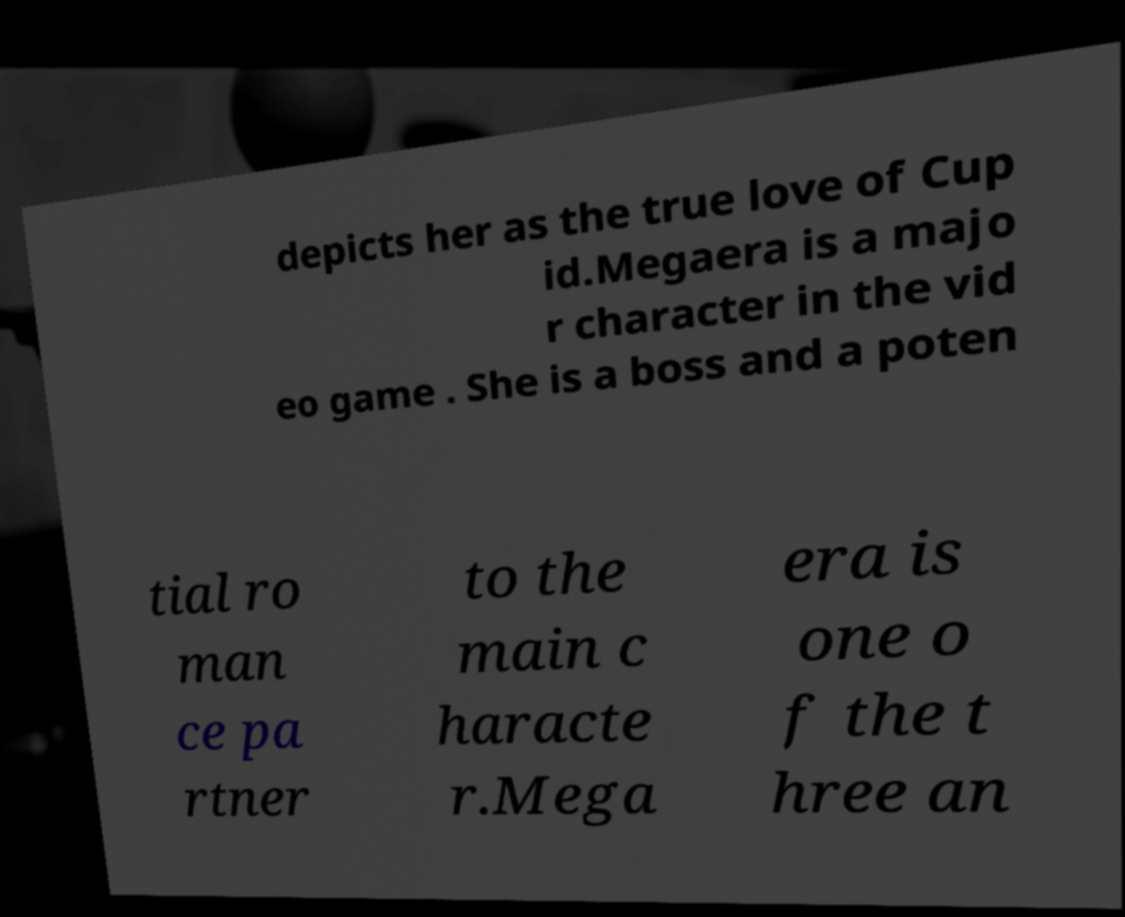I need the written content from this picture converted into text. Can you do that? depicts her as the true love of Cup id.Megaera is a majo r character in the vid eo game . She is a boss and a poten tial ro man ce pa rtner to the main c haracte r.Mega era is one o f the t hree an 